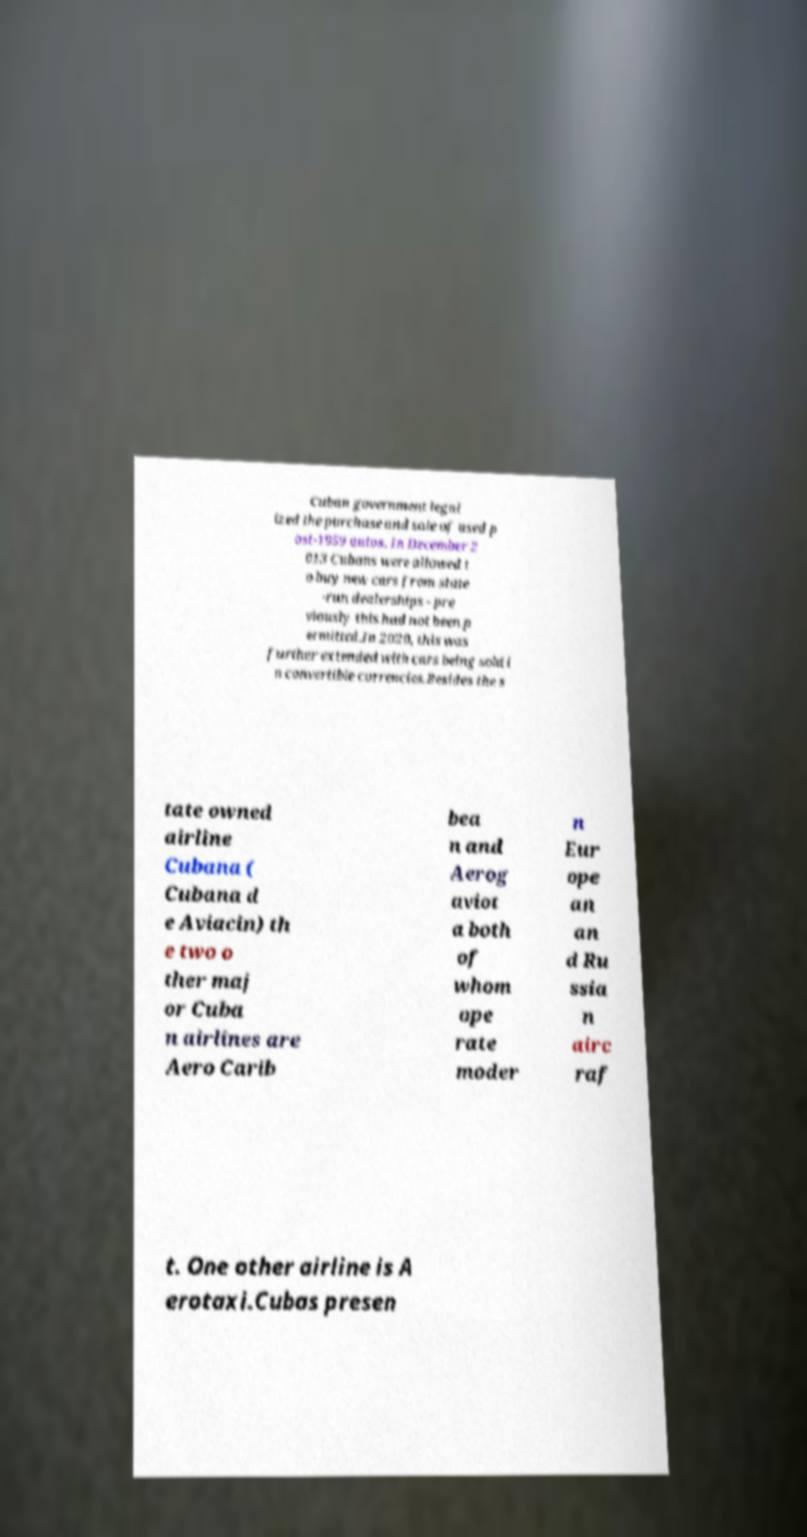There's text embedded in this image that I need extracted. Can you transcribe it verbatim? Cuban government legal ized the purchase and sale of used p ost-1959 autos. In December 2 013 Cubans were allowed t o buy new cars from state -run dealerships - pre viously this had not been p ermitted.In 2020, this was further extended with cars being sold i n convertible currencies.Besides the s tate owned airline Cubana ( Cubana d e Aviacin) th e two o ther maj or Cuba n airlines are Aero Carib bea n and Aerog aviot a both of whom ope rate moder n Eur ope an an d Ru ssia n airc raf t. One other airline is A erotaxi.Cubas presen 